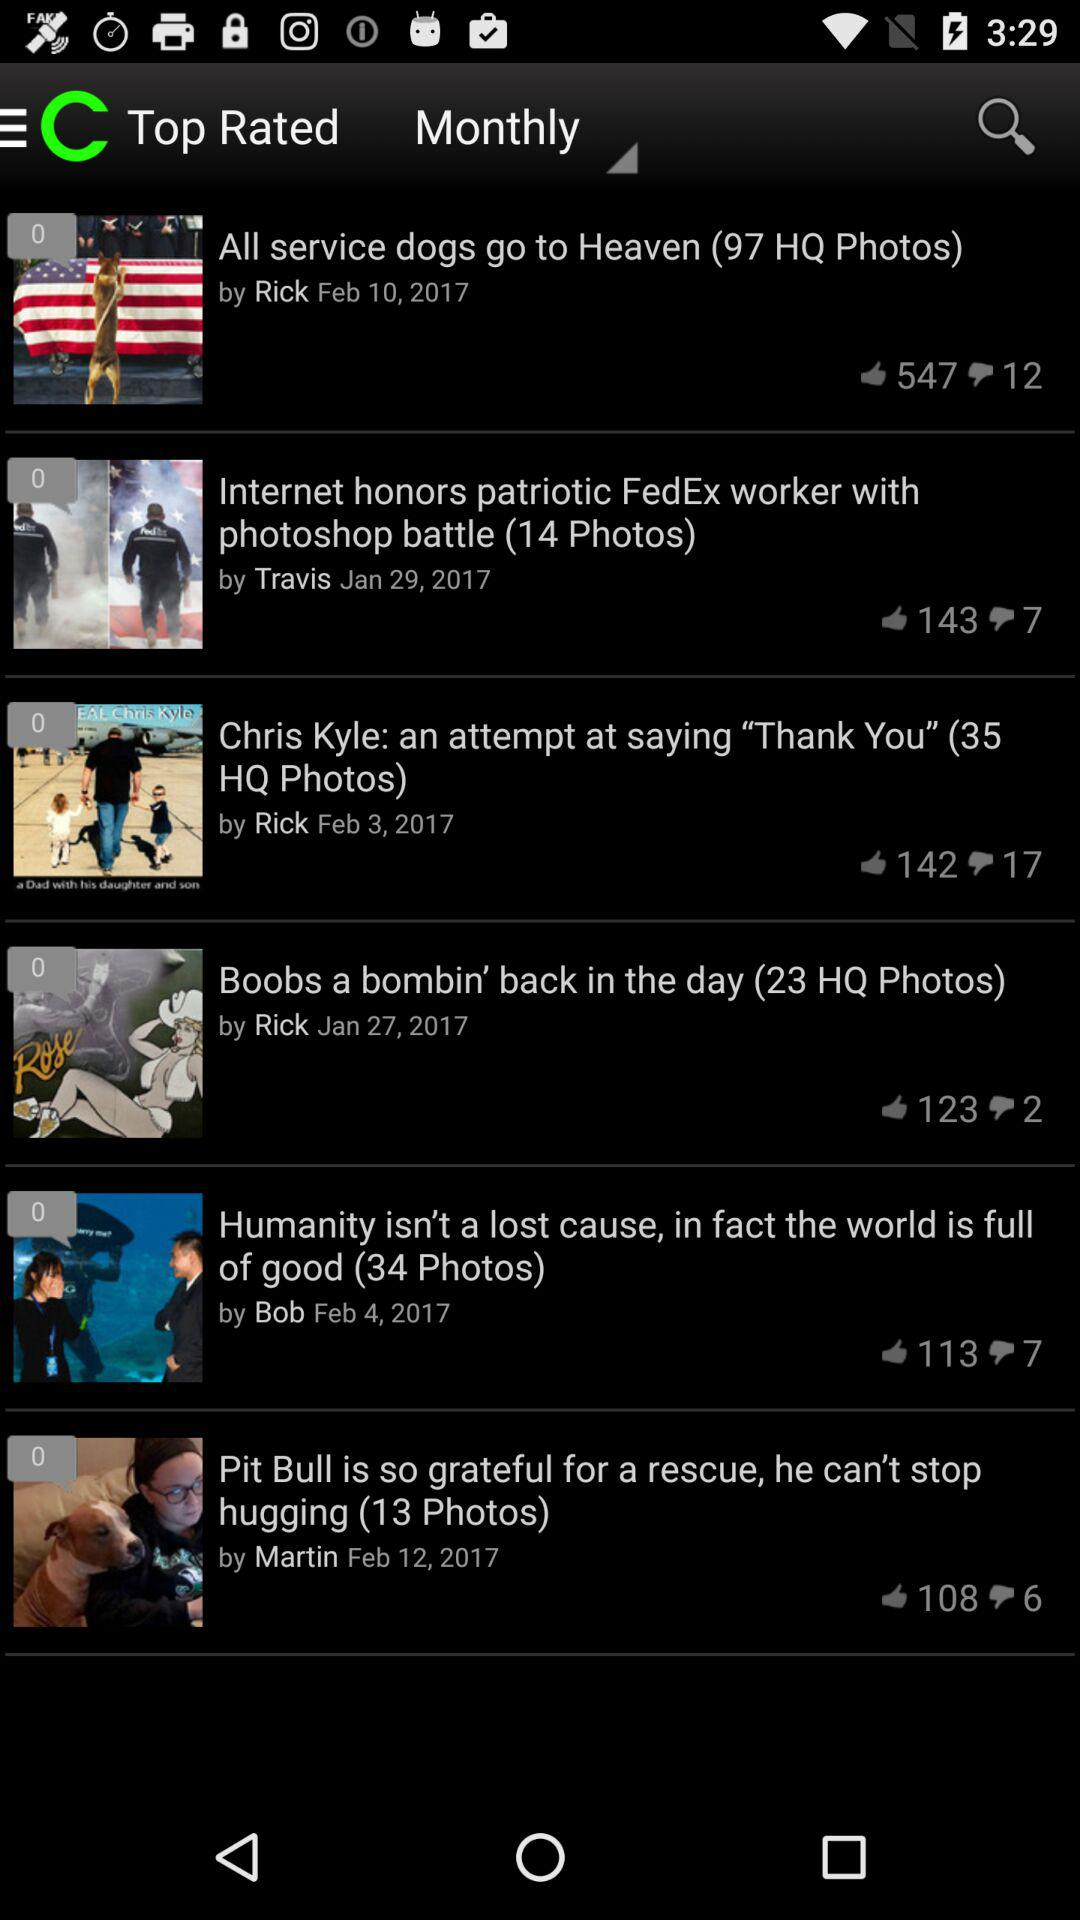Which news has 17 dislikes? The news "Chris Kyle: an attempt at saying "Thank You" (35 HQ Photos)" has 17 dislikes. 